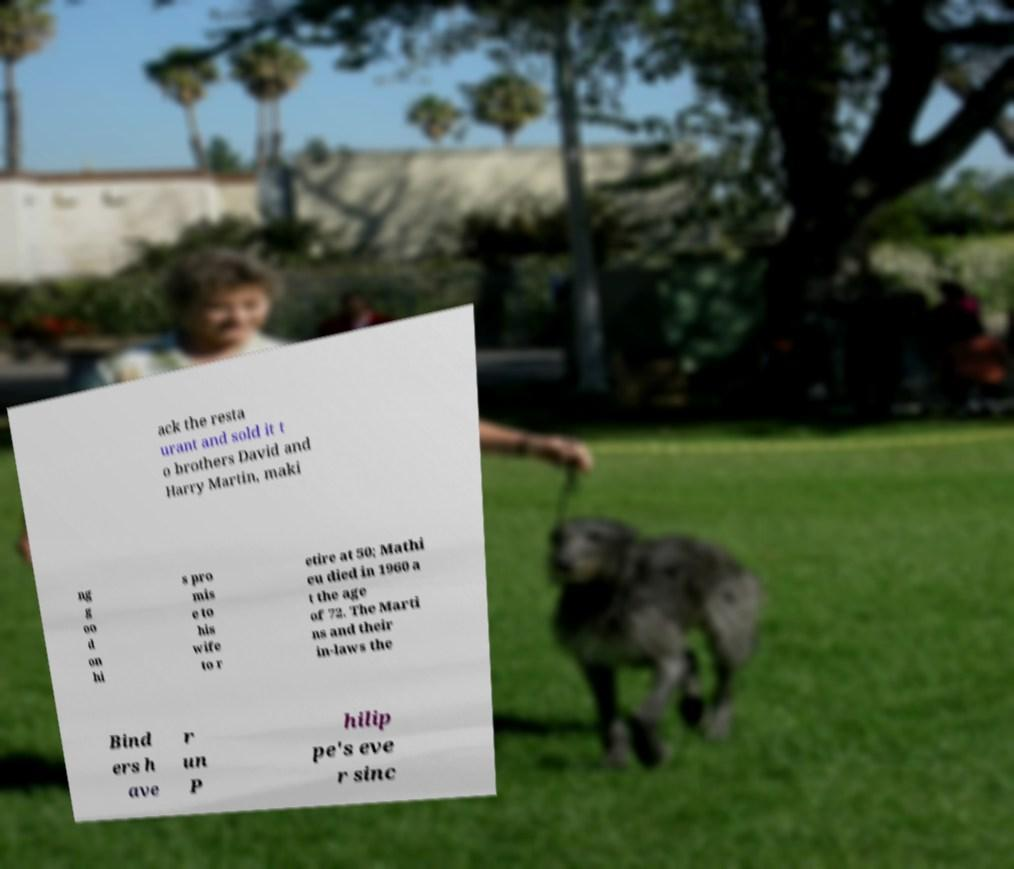I need the written content from this picture converted into text. Can you do that? ack the resta urant and sold it t o brothers David and Harry Martin, maki ng g oo d on hi s pro mis e to his wife to r etire at 50; Mathi eu died in 1960 a t the age of 72. The Marti ns and their in-laws the Bind ers h ave r un P hilip pe's eve r sinc 